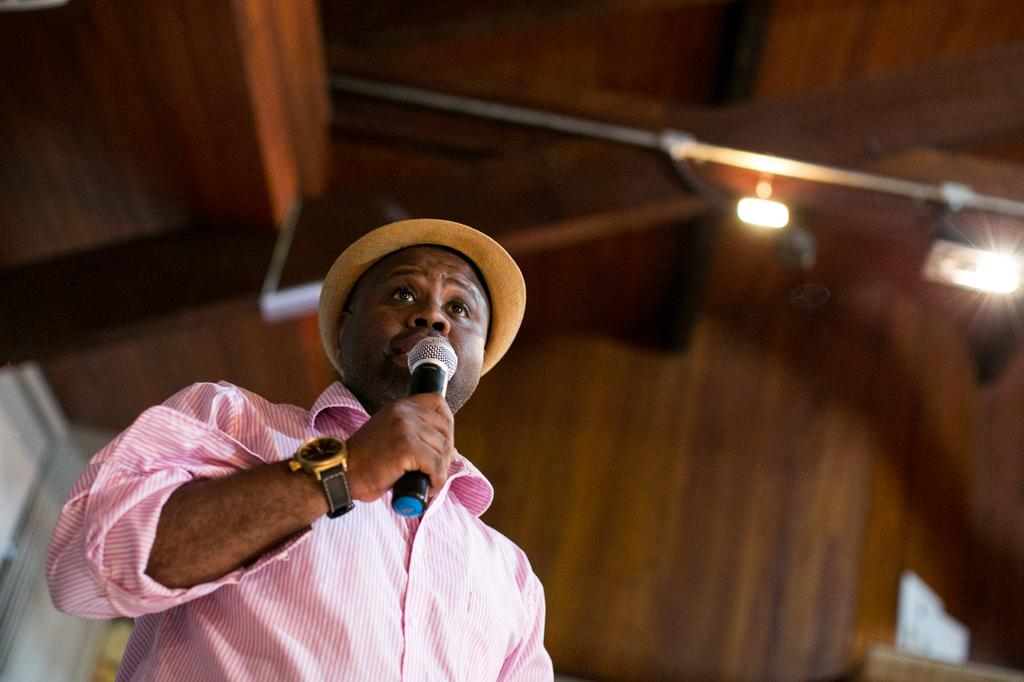Who is present in the image? There is a man in the image. What is the man wearing? The man is wearing a pink shirt. What is the man holding in the image? The man is holding a microphone. What can be seen in the background of the image? There is a roof and lights visible in the background of the image. Where is the cup placed in the image? There is no cup present in the image. What type of bed can be seen in the image? There is no bed present in the image. 